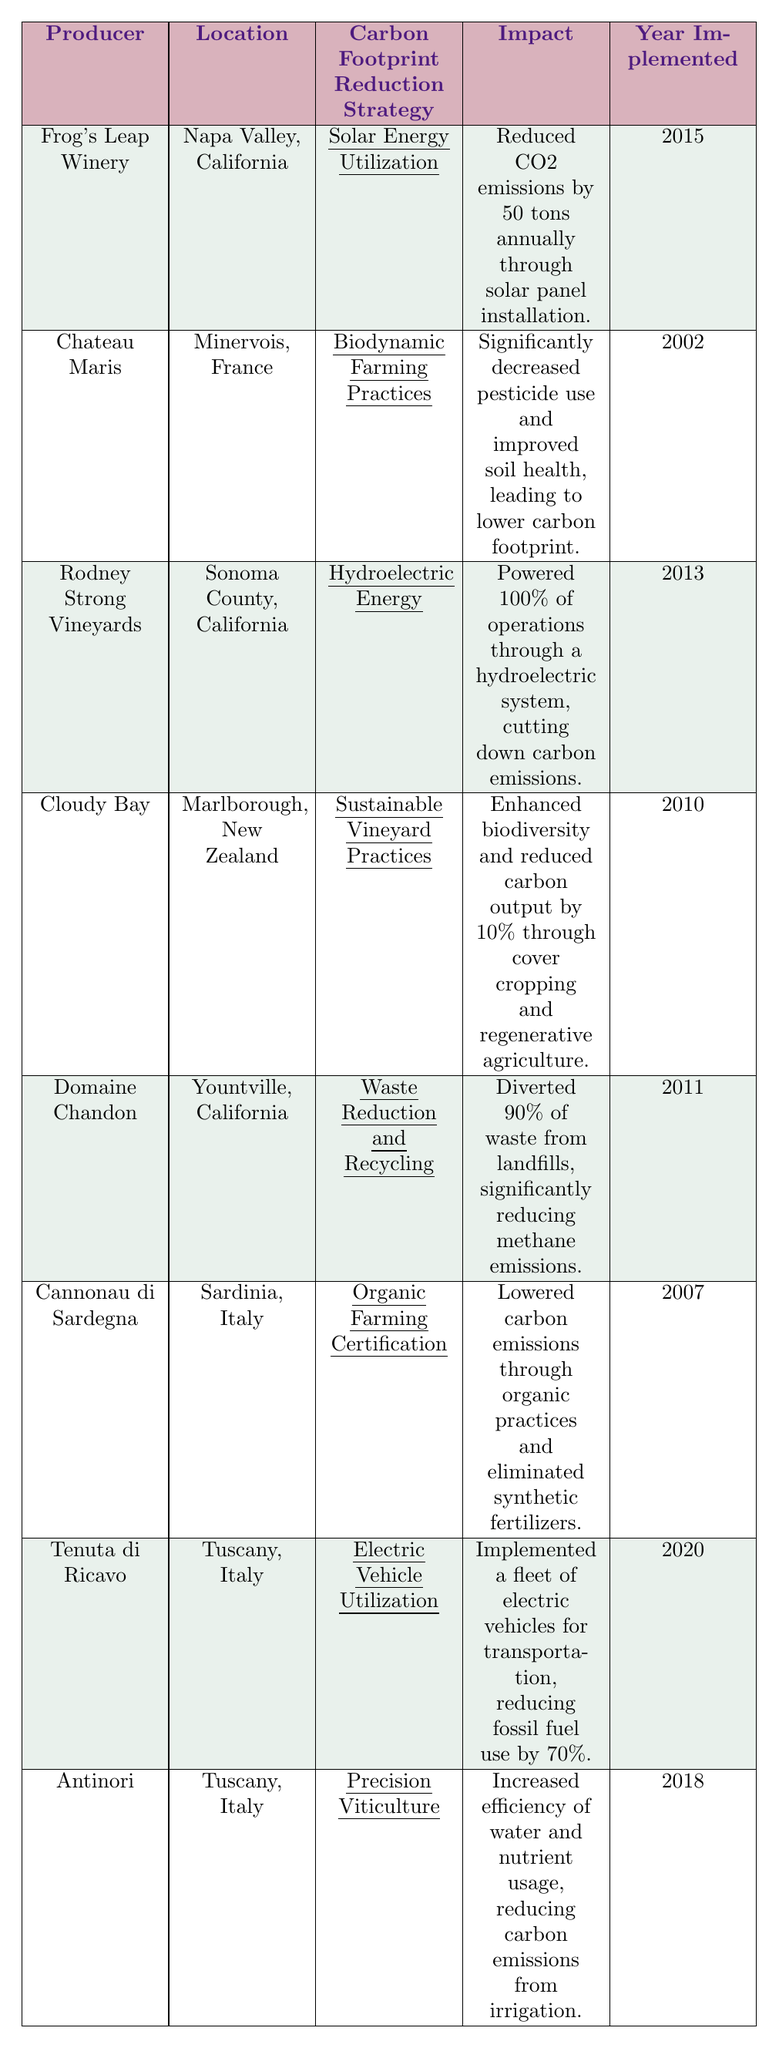What is the carbon footprint reduction strategy implemented by Frog's Leap Winery? According to the table, Frog's Leap Winery has implemented "Solar Energy Utilization" as its carbon footprint reduction strategy.
Answer: Solar Energy Utilization Which winery is located in Tuscany and utilizes electric vehicles? The table lists Tenuta di Ricavo as the winery located in Tuscany that has implemented electric vehicle utilization.
Answer: Tenuta di Ricavo How many tons of CO2 emissions does Frog's Leap Winery reduce annually? The table states that Frog's Leap Winery reduces CO2 emissions by 50 tons annually through its solar panel installation.
Answer: 50 tons Which producer started their carbon footprint reduction efforts the earliest? By checking the "Year Implemented" column, Chateau Maris, with the year 2002, is the earliest producer to start their carbon footprint reduction efforts.
Answer: Chateau Maris What is the common theme among the strategies of Cloudy Bay, Domaine Chandon, and Cannonau di Sardegna? All three strategies focus on sustainable practices: Cloudy Bay on sustainable vineyard practices, Domaine Chandon on waste reduction and recycling, and Cannonau di Sardegna on organic farming.
Answer: Sustainable practices Did any wine producers implement their strategies in 2020? The table indicates that Tenuta di Ricavo implemented its strategy in 2020, confirming that at least one producer did so in that year.
Answer: Yes What percentage of waste does Domaine Chandon divert from landfills? According to the table, Domaine Chandon diverts 90% of waste from landfills.
Answer: 90% Which strategies are implemented after 2015? By checking the "Year Implemented" column, the strategies after 2015 are Electric Vehicle Utilization, Precision Viticulture, and Tenuta di Ricavo's strategy.
Answer: Electric Vehicle Utilization, Precision Viticulture How does Rodney Strong Vineyards reduce its carbon emissions? The table reveals that Rodney Strong Vineyards reduces its carbon emissions by powering 100% of its operations through a hydroelectric system.
Answer: Hydroelectric system Which producer has both improved soil health and reduced pesticide use? The table shows that Chateau Maris has adopted biodynamic farming practices, which significantly decreased pesticide use and improved soil health.
Answer: Chateau Maris 